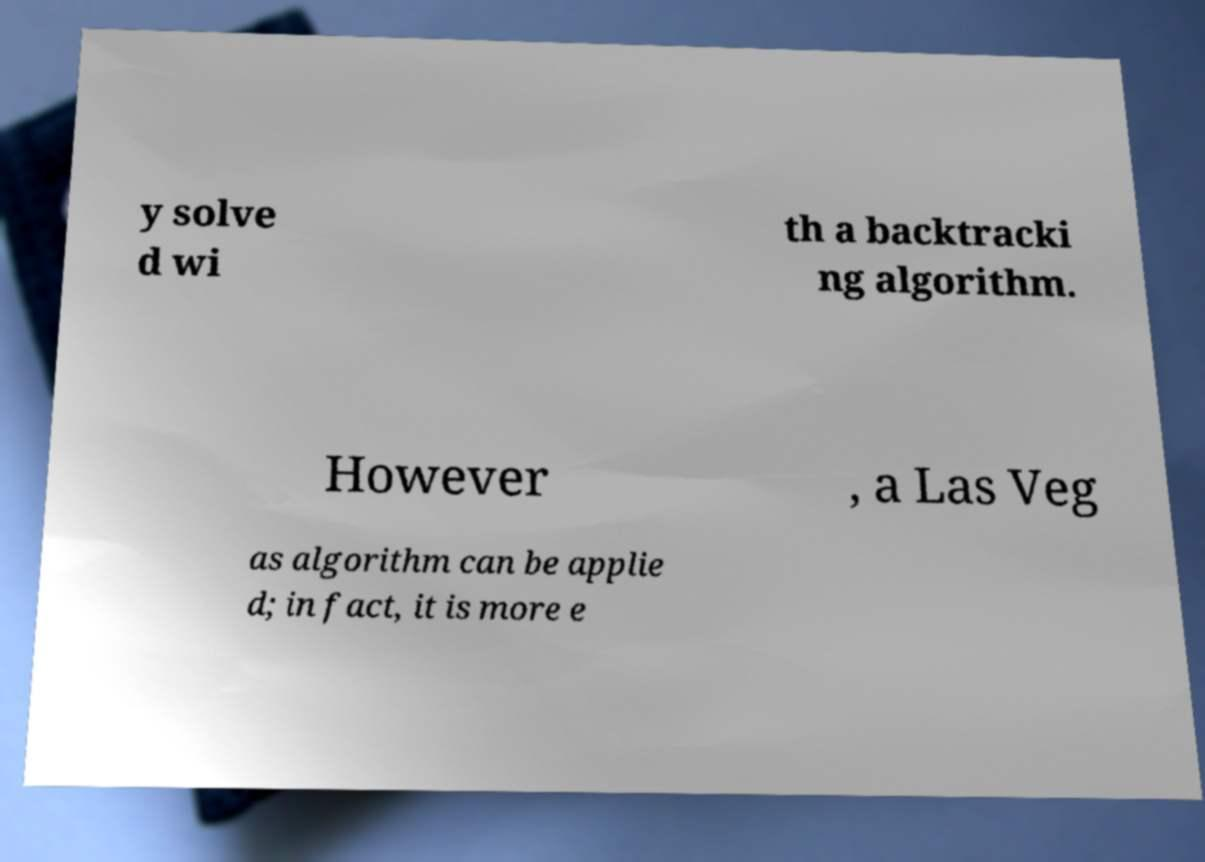There's text embedded in this image that I need extracted. Can you transcribe it verbatim? y solve d wi th a backtracki ng algorithm. However , a Las Veg as algorithm can be applie d; in fact, it is more e 